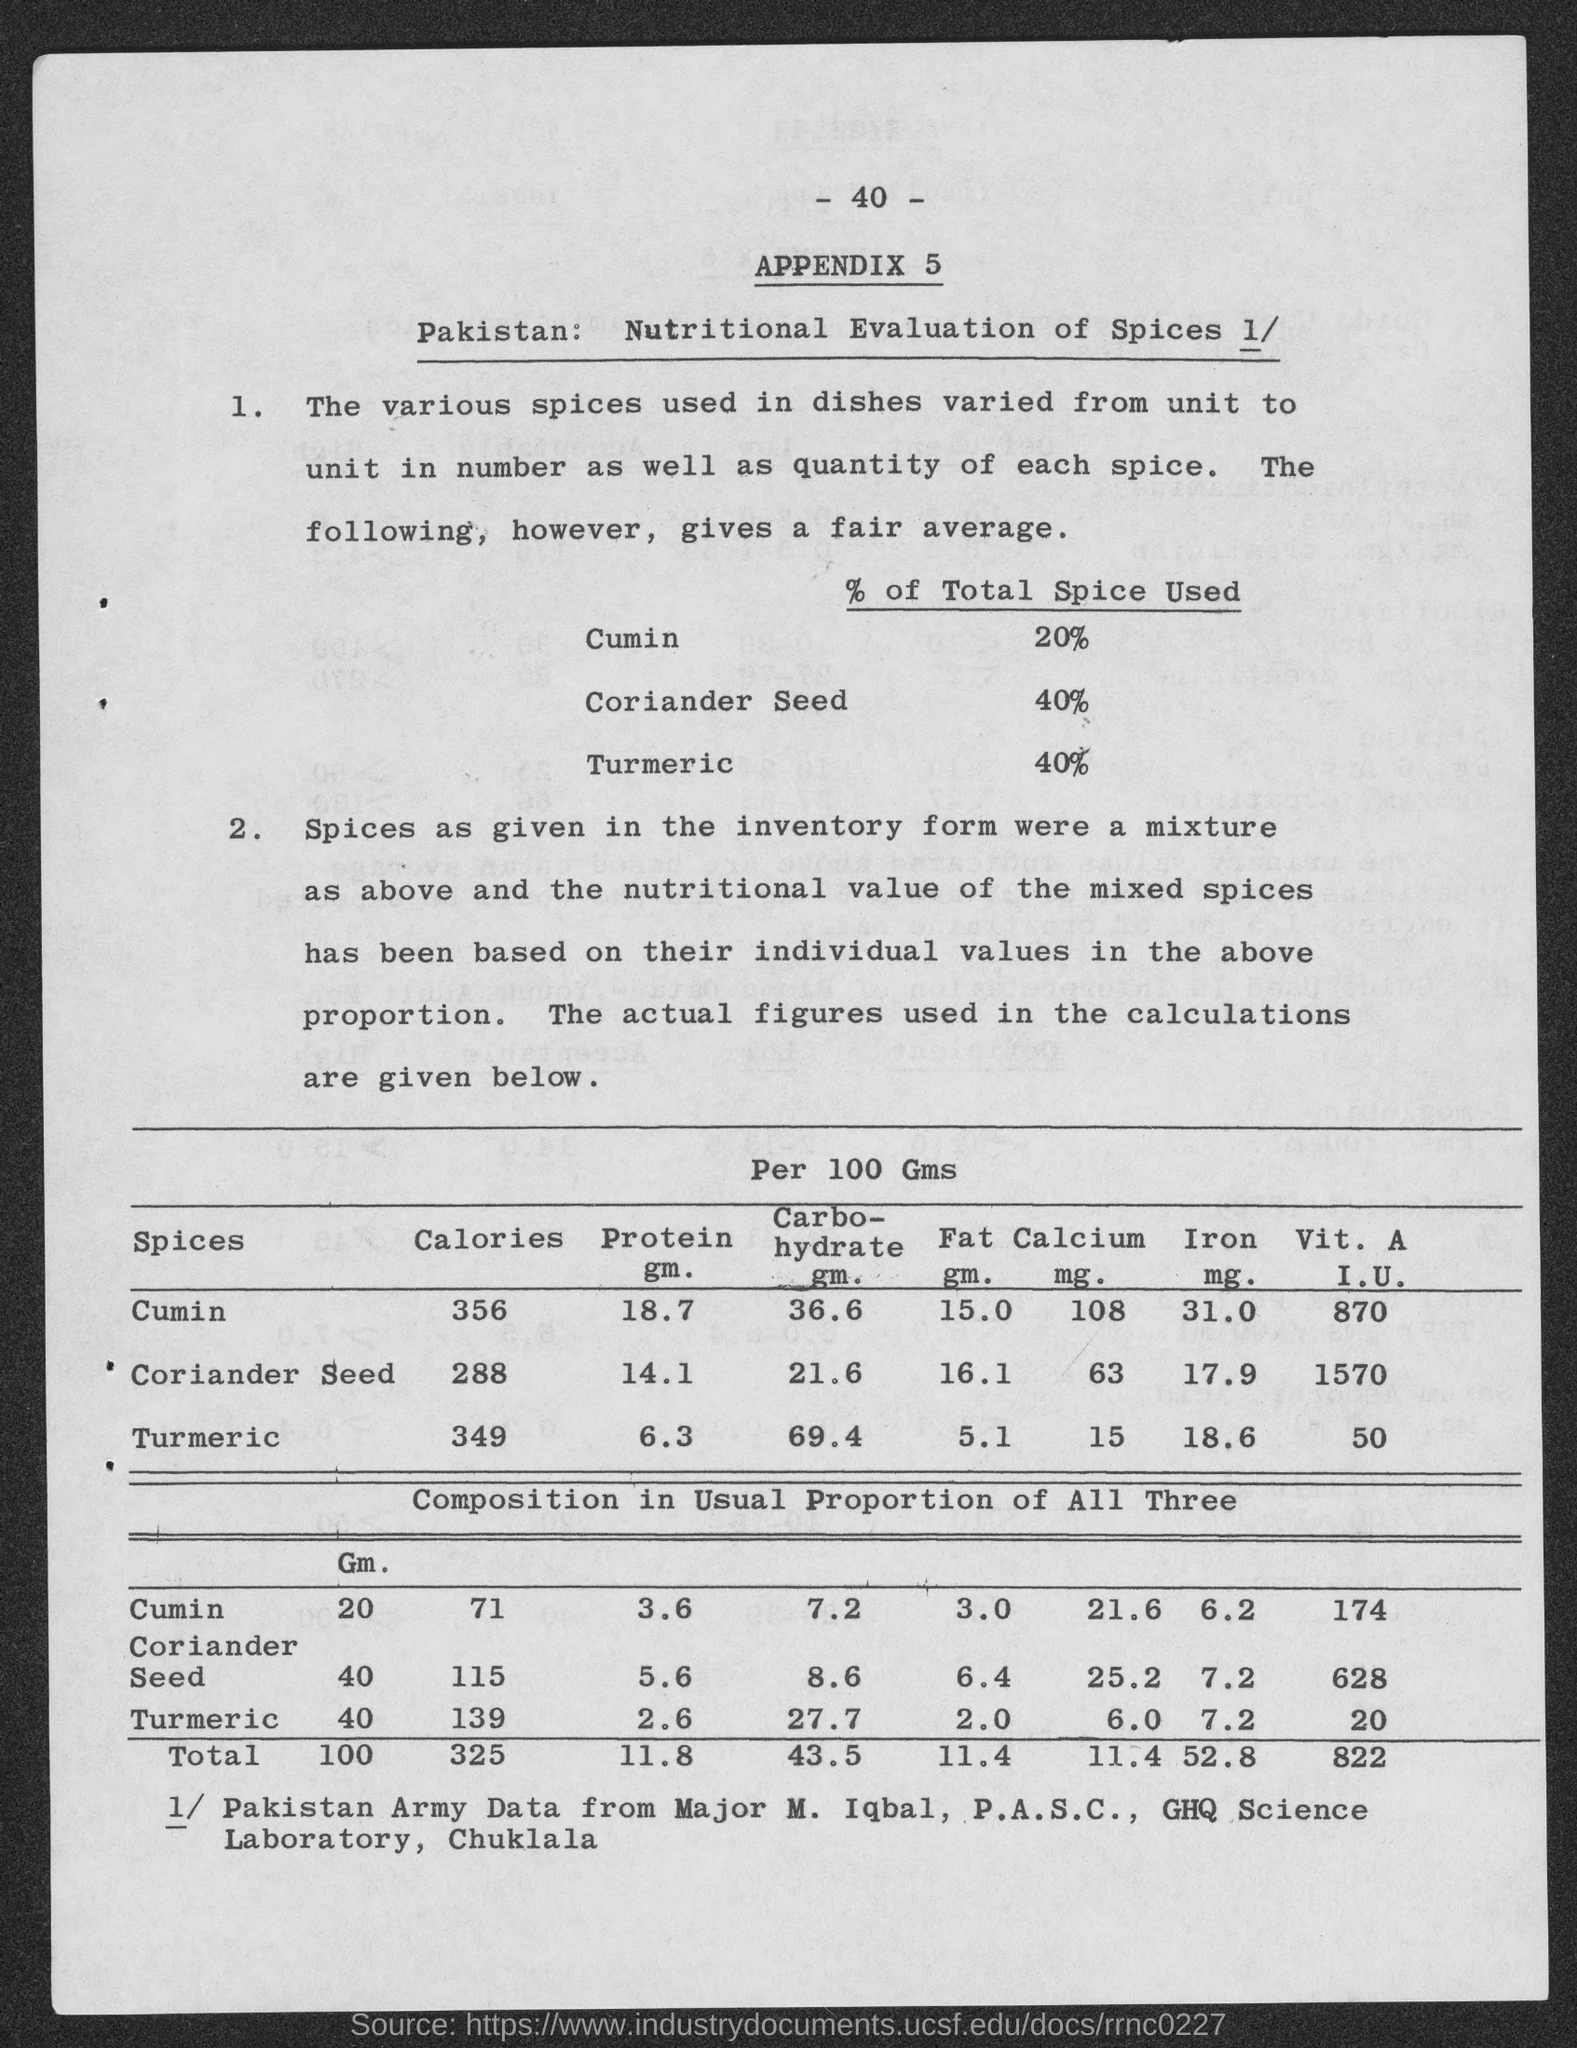Indicate a few pertinent items in this graphic. I am looking at a page with a number at the top that I perceive to be 40. What is the appendix number? 5. Approximately 40% of the total spice used is coriander seed. The total amount of turmeric used is 40%. The total spice used for cumin is 20%. 